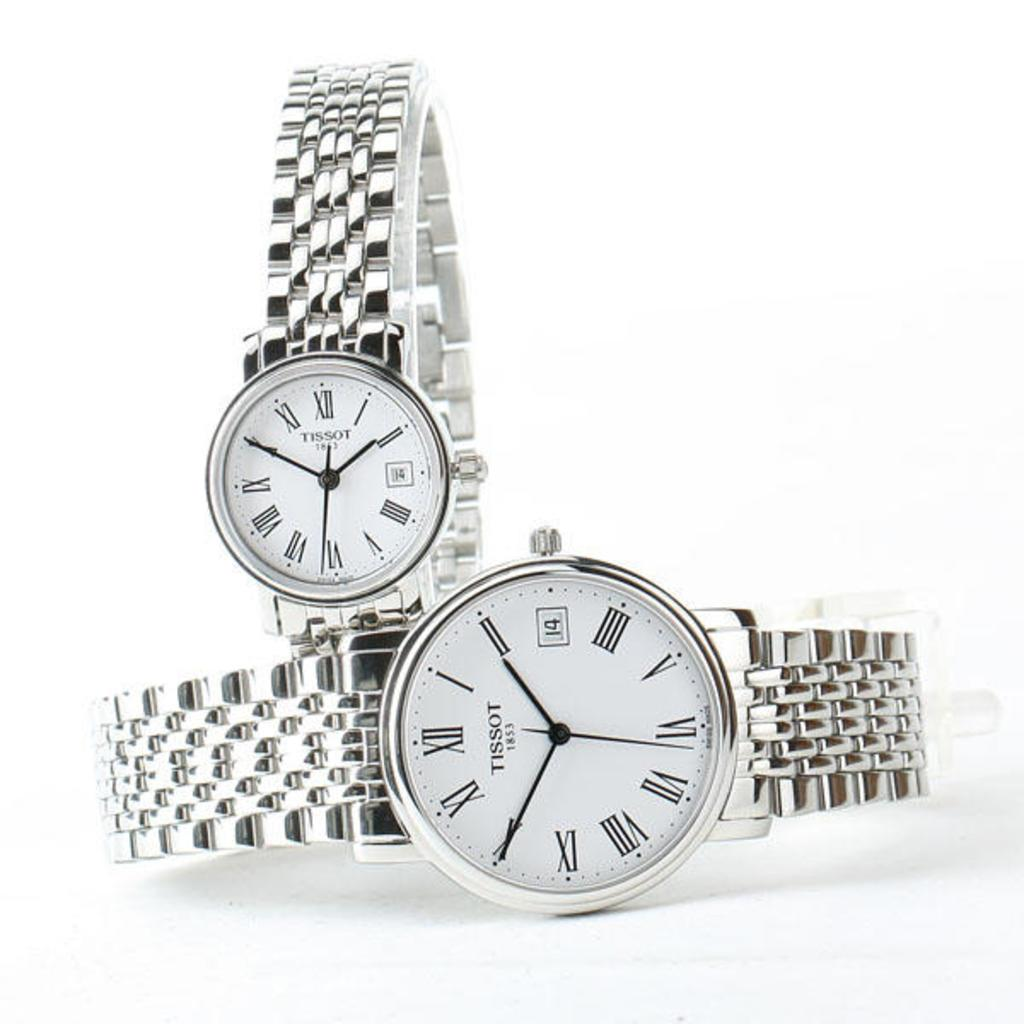Provide a one-sentence caption for the provided image. two silver Tissot 1853 watches on a white background. 